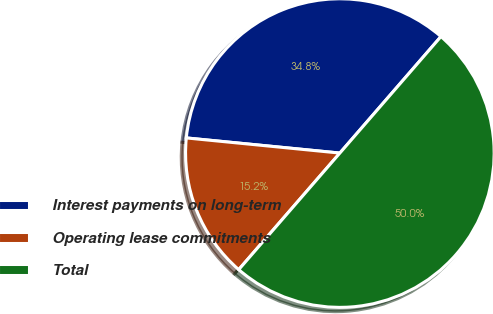<chart> <loc_0><loc_0><loc_500><loc_500><pie_chart><fcel>Interest payments on long-term<fcel>Operating lease commitments<fcel>Total<nl><fcel>34.81%<fcel>15.19%<fcel>50.0%<nl></chart> 